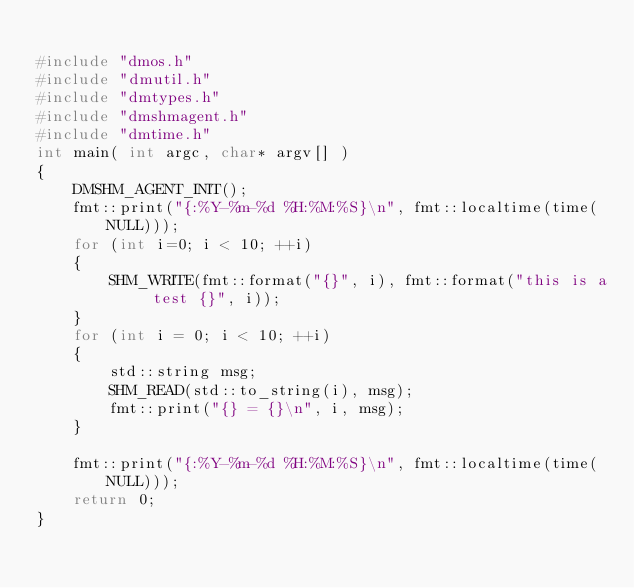Convert code to text. <code><loc_0><loc_0><loc_500><loc_500><_C++_>
#include "dmos.h"
#include "dmutil.h"
#include "dmtypes.h"
#include "dmshmagent.h"
#include "dmtime.h"
int main( int argc, char* argv[] )
{
    DMSHM_AGENT_INIT();
    fmt::print("{:%Y-%m-%d %H:%M:%S}\n", fmt::localtime(time(NULL)));
    for (int i=0; i < 10; ++i)
    {
        SHM_WRITE(fmt::format("{}", i), fmt::format("this is a test {}", i));
    }
    for (int i = 0; i < 10; ++i)
    {
        std::string msg;
        SHM_READ(std::to_string(i), msg);
        fmt::print("{} = {}\n", i, msg);
    }

    fmt::print("{:%Y-%m-%d %H:%M:%S}\n", fmt::localtime(time(NULL)));
    return 0;
}
</code> 